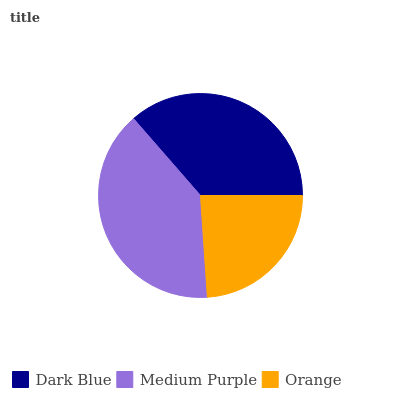Is Orange the minimum?
Answer yes or no. Yes. Is Medium Purple the maximum?
Answer yes or no. Yes. Is Medium Purple the minimum?
Answer yes or no. No. Is Orange the maximum?
Answer yes or no. No. Is Medium Purple greater than Orange?
Answer yes or no. Yes. Is Orange less than Medium Purple?
Answer yes or no. Yes. Is Orange greater than Medium Purple?
Answer yes or no. No. Is Medium Purple less than Orange?
Answer yes or no. No. Is Dark Blue the high median?
Answer yes or no. Yes. Is Dark Blue the low median?
Answer yes or no. Yes. Is Orange the high median?
Answer yes or no. No. Is Medium Purple the low median?
Answer yes or no. No. 